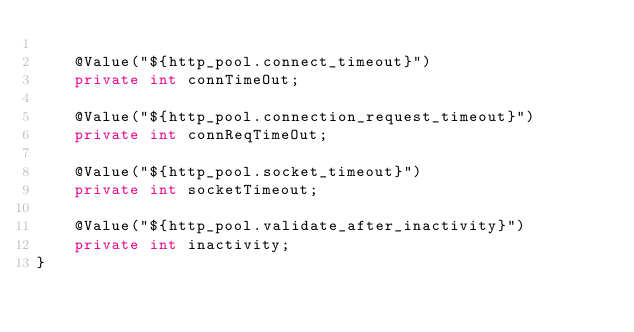<code> <loc_0><loc_0><loc_500><loc_500><_Java_>
    @Value("${http_pool.connect_timeout}")
    private int connTimeOut;

    @Value("${http_pool.connection_request_timeout}")
    private int connReqTimeOut;

    @Value("${http_pool.socket_timeout}")
    private int socketTimeout;

    @Value("${http_pool.validate_after_inactivity}")
    private int inactivity;
}
</code> 